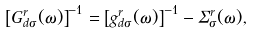Convert formula to latex. <formula><loc_0><loc_0><loc_500><loc_500>\left [ G _ { d \sigma } ^ { r } ( \omega ) \right ] ^ { - 1 } = \left [ g _ { d \sigma } ^ { r } ( \omega ) \right ] ^ { - 1 } - \Sigma _ { \sigma } ^ { r } ( \omega ) ,</formula> 